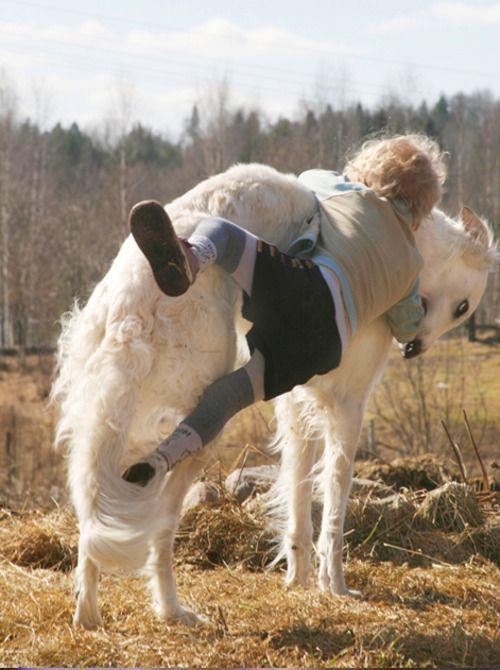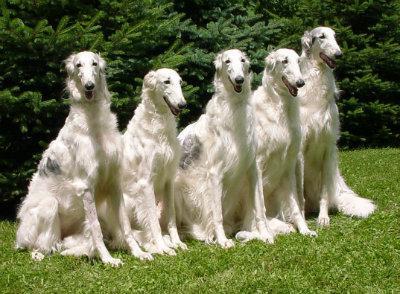The first image is the image on the left, the second image is the image on the right. Examine the images to the left and right. Is the description "There are two dogs" accurate? Answer yes or no. No. 